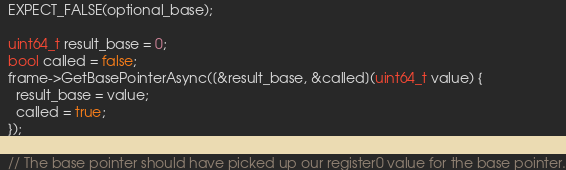<code> <loc_0><loc_0><loc_500><loc_500><_C++_>  EXPECT_FALSE(optional_base);

  uint64_t result_base = 0;
  bool called = false;
  frame->GetBasePointerAsync([&result_base, &called](uint64_t value) {
    result_base = value;
    called = true;
  });

  // The base pointer should have picked up our register0 value for the base pointer.</code> 